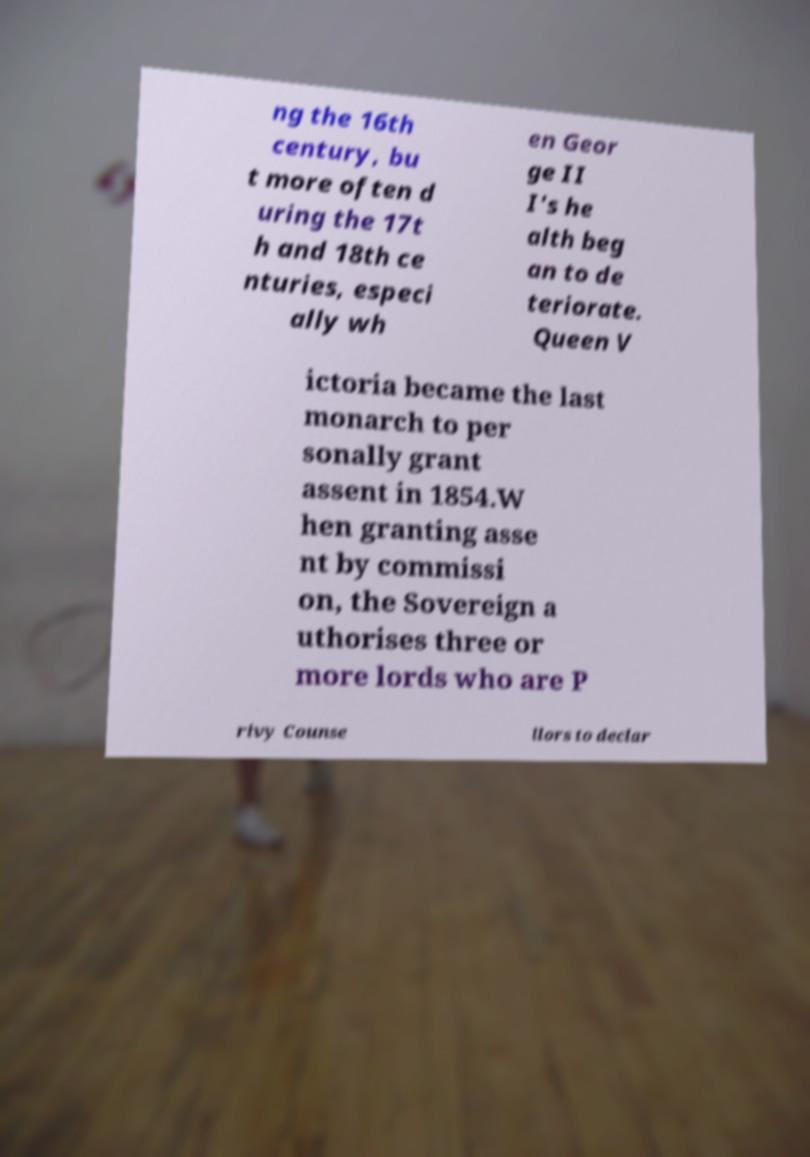Could you assist in decoding the text presented in this image and type it out clearly? ng the 16th century, bu t more often d uring the 17t h and 18th ce nturies, especi ally wh en Geor ge II I's he alth beg an to de teriorate. Queen V ictoria became the last monarch to per sonally grant assent in 1854.W hen granting asse nt by commissi on, the Sovereign a uthorises three or more lords who are P rivy Counse llors to declar 